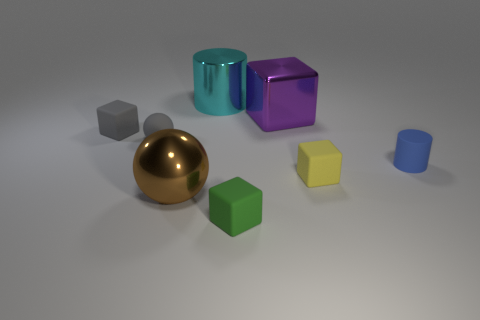How many other objects are there of the same color as the metallic ball?
Keep it short and to the point. 0. Do the metal sphere and the matte cylinder have the same color?
Your answer should be very brief. No. How many red matte spheres are there?
Provide a succinct answer. 0. What is the material of the block behind the tiny cube that is on the left side of the tiny green object?
Your response must be concise. Metal. There is a yellow cube that is the same size as the blue matte cylinder; what material is it?
Provide a succinct answer. Rubber. Do the rubber object that is in front of the yellow cube and the blue object have the same size?
Provide a short and direct response. Yes. There is a large metallic object that is in front of the tiny cylinder; is it the same shape as the purple object?
Ensure brevity in your answer.  No. What number of things are rubber blocks or small rubber objects that are right of the tiny sphere?
Your answer should be very brief. 4. Is the number of blue metal cylinders less than the number of purple metal things?
Provide a short and direct response. Yes. Are there more big metallic cylinders than large red rubber cubes?
Keep it short and to the point. Yes. 